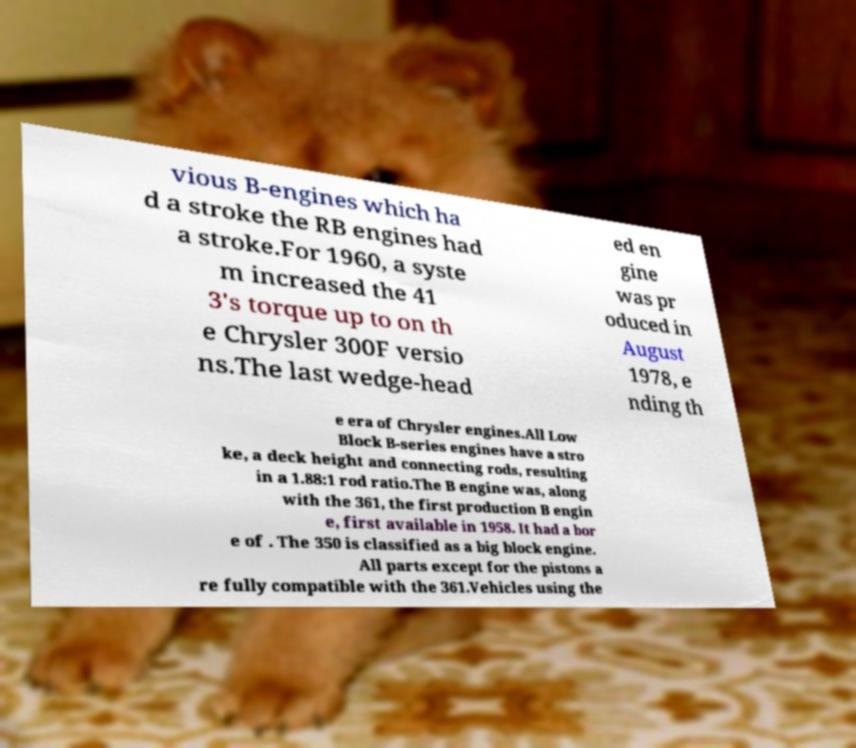Could you assist in decoding the text presented in this image and type it out clearly? vious B-engines which ha d a stroke the RB engines had a stroke.For 1960, a syste m increased the 41 3's torque up to on th e Chrysler 300F versio ns.The last wedge-head ed en gine was pr oduced in August 1978, e nding th e era of Chrysler engines.All Low Block B-series engines have a stro ke, a deck height and connecting rods, resulting in a 1.88:1 rod ratio.The B engine was, along with the 361, the first production B engin e, first available in 1958. It had a bor e of . The 350 is classified as a big block engine. All parts except for the pistons a re fully compatible with the 361.Vehicles using the 